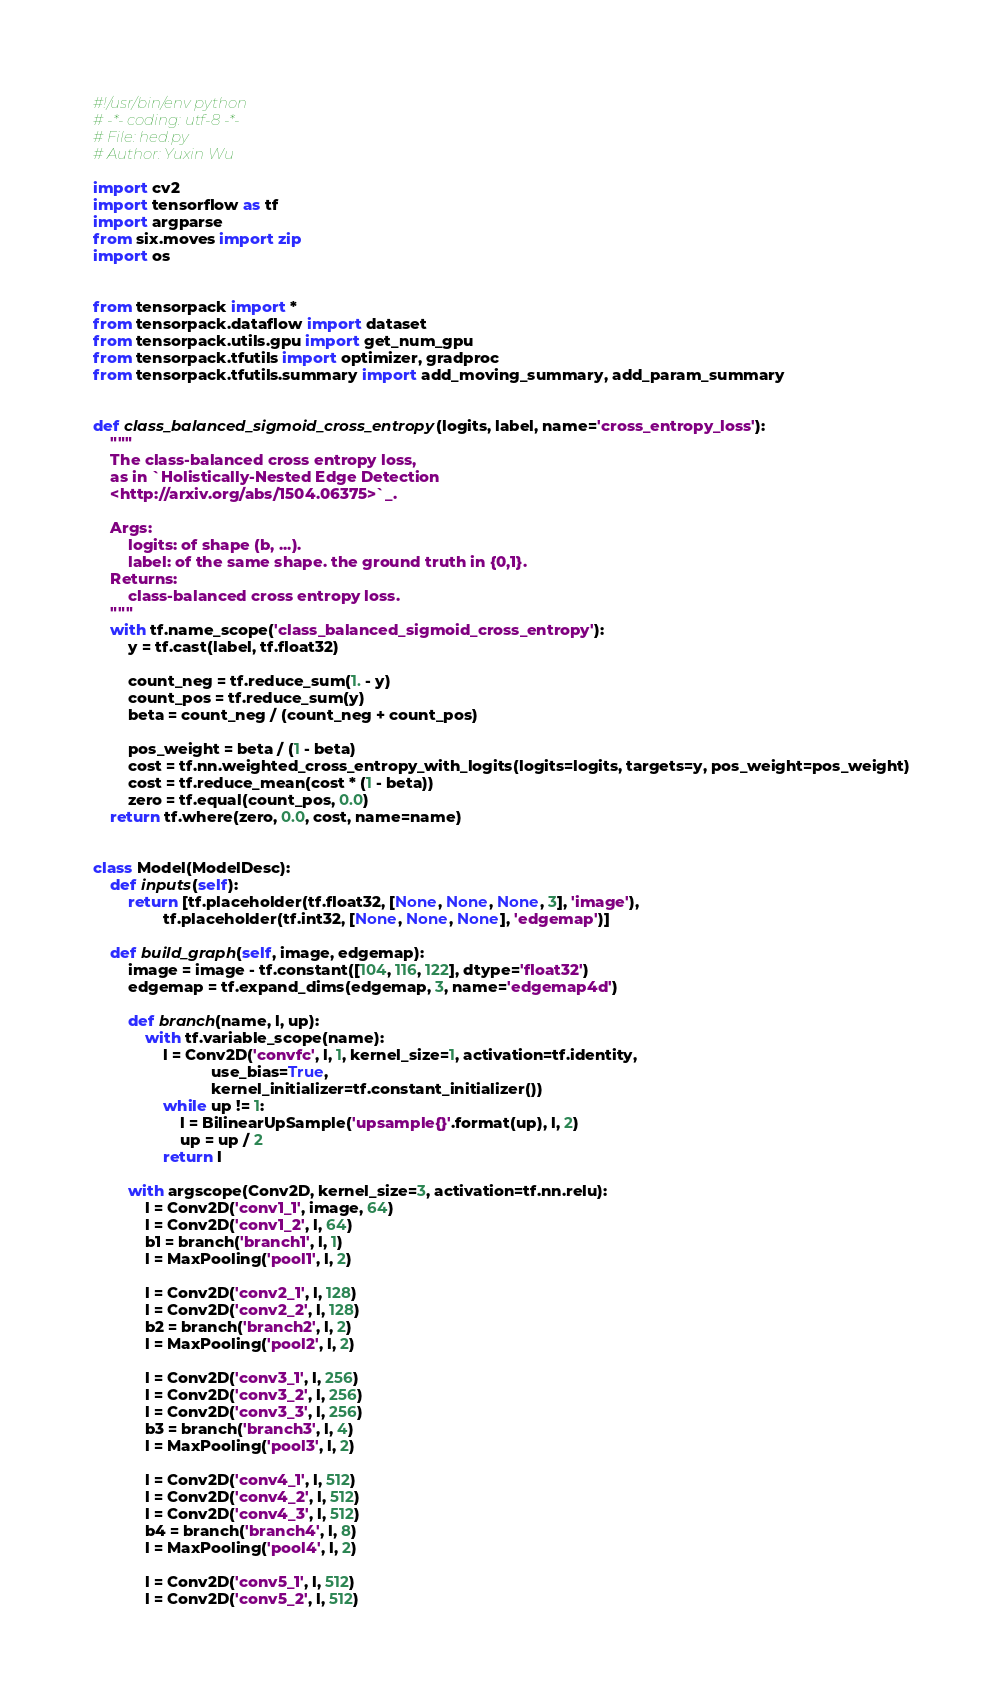Convert code to text. <code><loc_0><loc_0><loc_500><loc_500><_Python_>#!/usr/bin/env python
# -*- coding: utf-8 -*-
# File: hed.py
# Author: Yuxin Wu

import cv2
import tensorflow as tf
import argparse
from six.moves import zip
import os


from tensorpack import *
from tensorpack.dataflow import dataset
from tensorpack.utils.gpu import get_num_gpu
from tensorpack.tfutils import optimizer, gradproc
from tensorpack.tfutils.summary import add_moving_summary, add_param_summary


def class_balanced_sigmoid_cross_entropy(logits, label, name='cross_entropy_loss'):
    """
    The class-balanced cross entropy loss,
    as in `Holistically-Nested Edge Detection
    <http://arxiv.org/abs/1504.06375>`_.

    Args:
        logits: of shape (b, ...).
        label: of the same shape. the ground truth in {0,1}.
    Returns:
        class-balanced cross entropy loss.
    """
    with tf.name_scope('class_balanced_sigmoid_cross_entropy'):
        y = tf.cast(label, tf.float32)

        count_neg = tf.reduce_sum(1. - y)
        count_pos = tf.reduce_sum(y)
        beta = count_neg / (count_neg + count_pos)

        pos_weight = beta / (1 - beta)
        cost = tf.nn.weighted_cross_entropy_with_logits(logits=logits, targets=y, pos_weight=pos_weight)
        cost = tf.reduce_mean(cost * (1 - beta))
        zero = tf.equal(count_pos, 0.0)
    return tf.where(zero, 0.0, cost, name=name)


class Model(ModelDesc):
    def inputs(self):
        return [tf.placeholder(tf.float32, [None, None, None, 3], 'image'),
                tf.placeholder(tf.int32, [None, None, None], 'edgemap')]

    def build_graph(self, image, edgemap):
        image = image - tf.constant([104, 116, 122], dtype='float32')
        edgemap = tf.expand_dims(edgemap, 3, name='edgemap4d')

        def branch(name, l, up):
            with tf.variable_scope(name):
                l = Conv2D('convfc', l, 1, kernel_size=1, activation=tf.identity,
                           use_bias=True,
                           kernel_initializer=tf.constant_initializer())
                while up != 1:
                    l = BilinearUpSample('upsample{}'.format(up), l, 2)
                    up = up / 2
                return l

        with argscope(Conv2D, kernel_size=3, activation=tf.nn.relu):
            l = Conv2D('conv1_1', image, 64)
            l = Conv2D('conv1_2', l, 64)
            b1 = branch('branch1', l, 1)
            l = MaxPooling('pool1', l, 2)

            l = Conv2D('conv2_1', l, 128)
            l = Conv2D('conv2_2', l, 128)
            b2 = branch('branch2', l, 2)
            l = MaxPooling('pool2', l, 2)

            l = Conv2D('conv3_1', l, 256)
            l = Conv2D('conv3_2', l, 256)
            l = Conv2D('conv3_3', l, 256)
            b3 = branch('branch3', l, 4)
            l = MaxPooling('pool3', l, 2)

            l = Conv2D('conv4_1', l, 512)
            l = Conv2D('conv4_2', l, 512)
            l = Conv2D('conv4_3', l, 512)
            b4 = branch('branch4', l, 8)
            l = MaxPooling('pool4', l, 2)

            l = Conv2D('conv5_1', l, 512)
            l = Conv2D('conv5_2', l, 512)</code> 